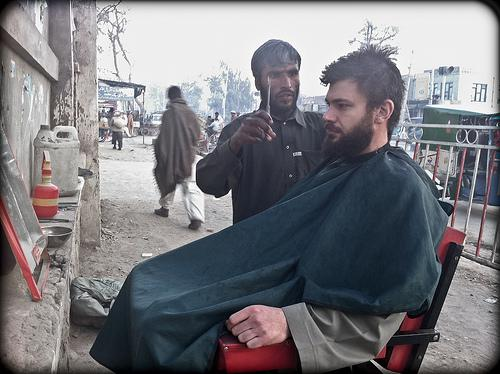Question: how many beards in the picture?
Choices:
A. 3.
B. 4.
C. 2.
D. 5.
Answer with the letter. Answer: C Question: where is te man sitting?
Choices:
A. On a bench.
B. In a chair.
C. On a tractor.
D. On a fence.
Answer with the letter. Answer: B Question: why is one man holding scissors?
Choices:
A. He is trimming the other man's hair.
B. Hes cutting a string.
C. Hes giving them to a child.
D. Hes trimming paper.
Answer with the letter. Answer: A Question: who is getting a trim?
Choices:
A. A family.
B. A woman.
C. School children.
D. A man.
Answer with the letter. Answer: D 